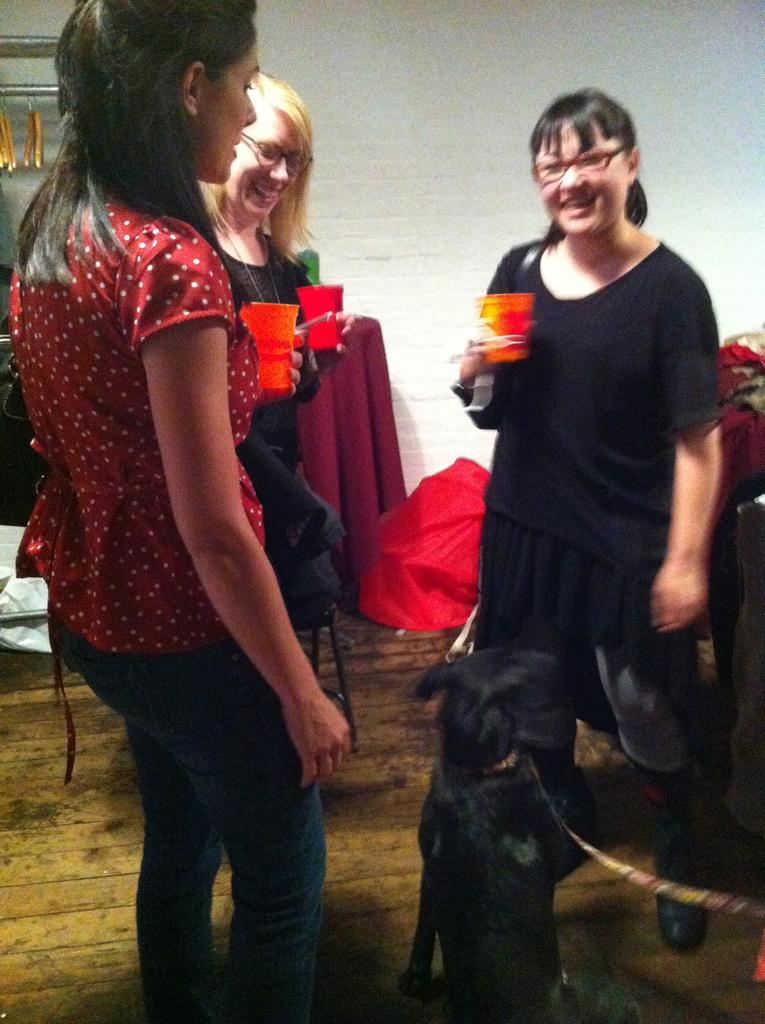How many people are in the image? There is a group of persons in the image. What are the people in the image doing? The persons are standing and holding glasses in their hands. What is the facial expression of the people in the image? The persons are smiling. What can be seen in the background of the image? There are objects in the background of the image. What colors are the objects in the background? The objects in the background are red and black in color. Can you tell me how many yams are being held by the persons in the image? There are no yams present in the image; the persons are holding glasses. What type of horse can be seen in the image? There is no horse present in the image. 